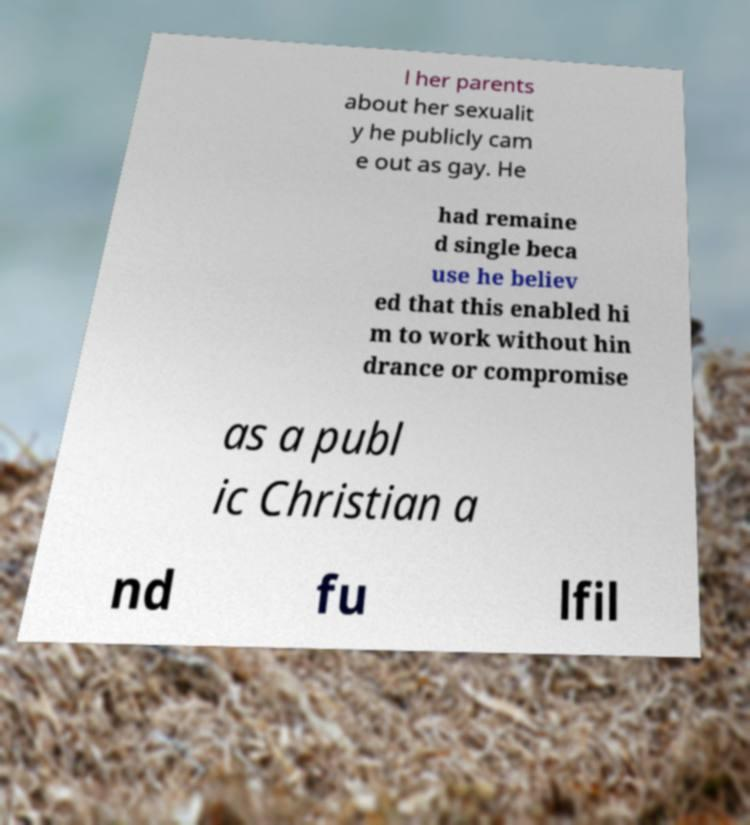There's text embedded in this image that I need extracted. Can you transcribe it verbatim? l her parents about her sexualit y he publicly cam e out as gay. He had remaine d single beca use he believ ed that this enabled hi m to work without hin drance or compromise as a publ ic Christian a nd fu lfil 